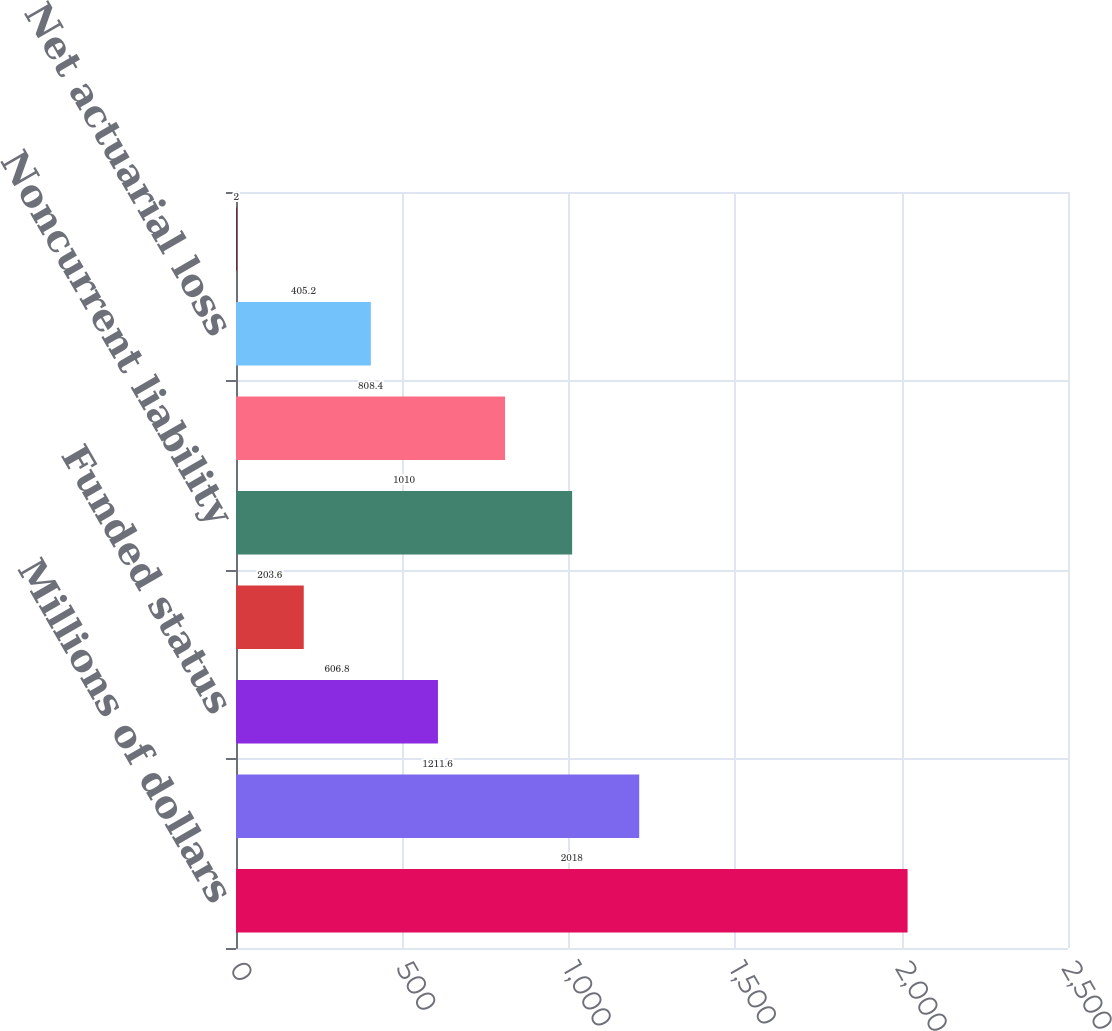Convert chart to OTSL. <chart><loc_0><loc_0><loc_500><loc_500><bar_chart><fcel>Millions of dollars<fcel>Benefit obligations<fcel>Funded status<fcel>Current liability<fcel>Noncurrent liability<fcel>Amount recognized<fcel>Net actuarial loss<fcel>Prior service (credit) cost<nl><fcel>2018<fcel>1211.6<fcel>606.8<fcel>203.6<fcel>1010<fcel>808.4<fcel>405.2<fcel>2<nl></chart> 